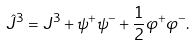Convert formula to latex. <formula><loc_0><loc_0><loc_500><loc_500>\hat { J } ^ { 3 } = J ^ { 3 } + \psi ^ { + } \psi ^ { - } + \frac { 1 } { 2 } \varphi ^ { + } \varphi ^ { - } .</formula> 